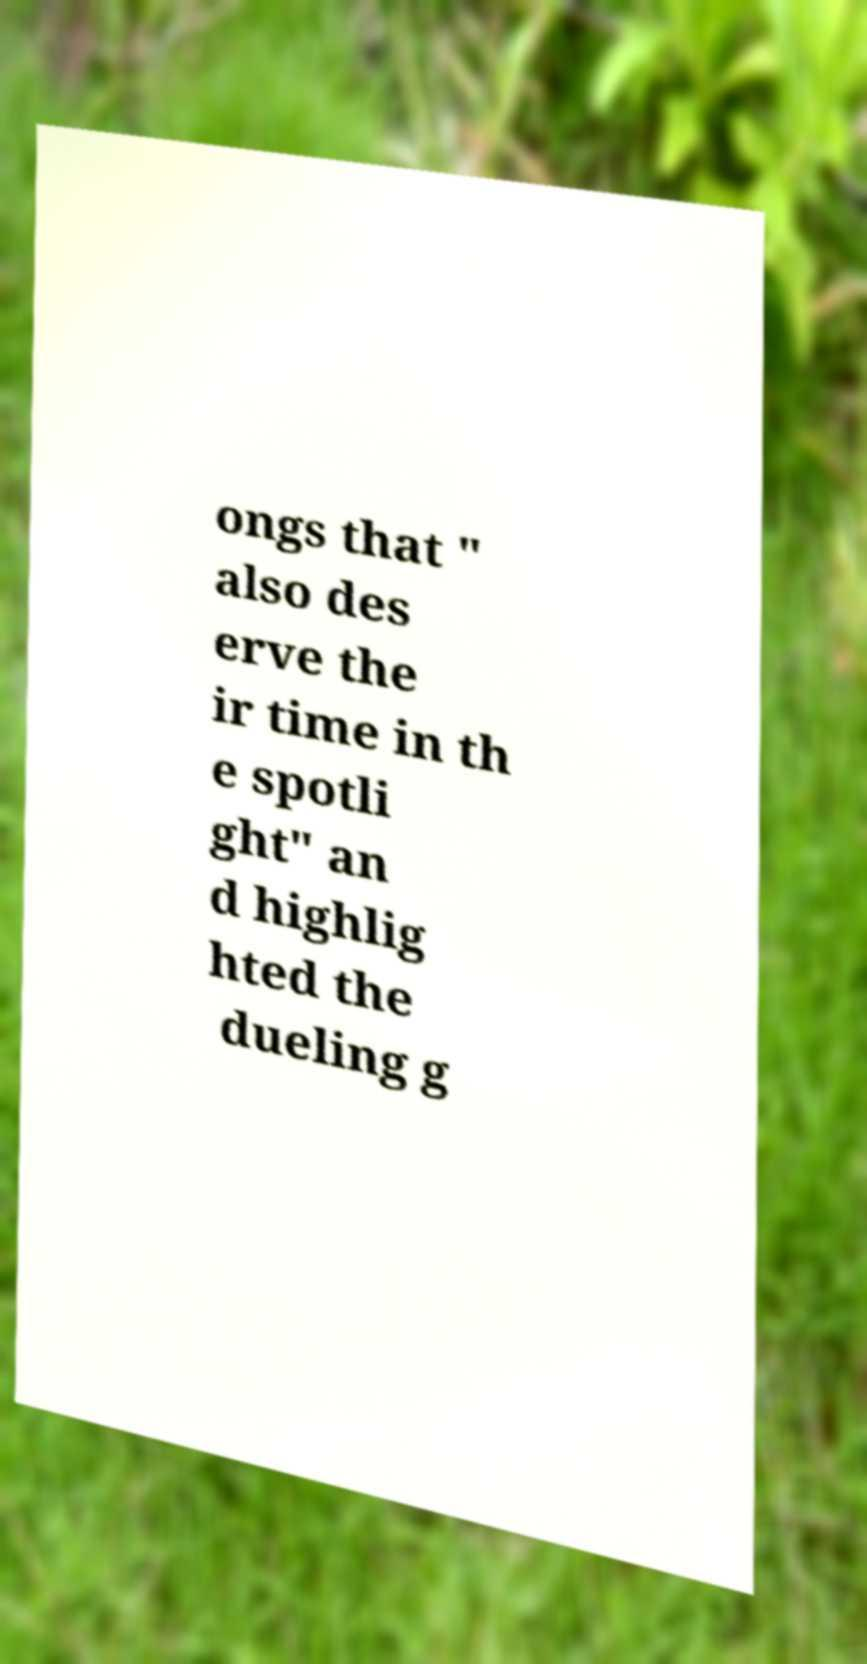Could you assist in decoding the text presented in this image and type it out clearly? ongs that " also des erve the ir time in th e spotli ght" an d highlig hted the dueling g 